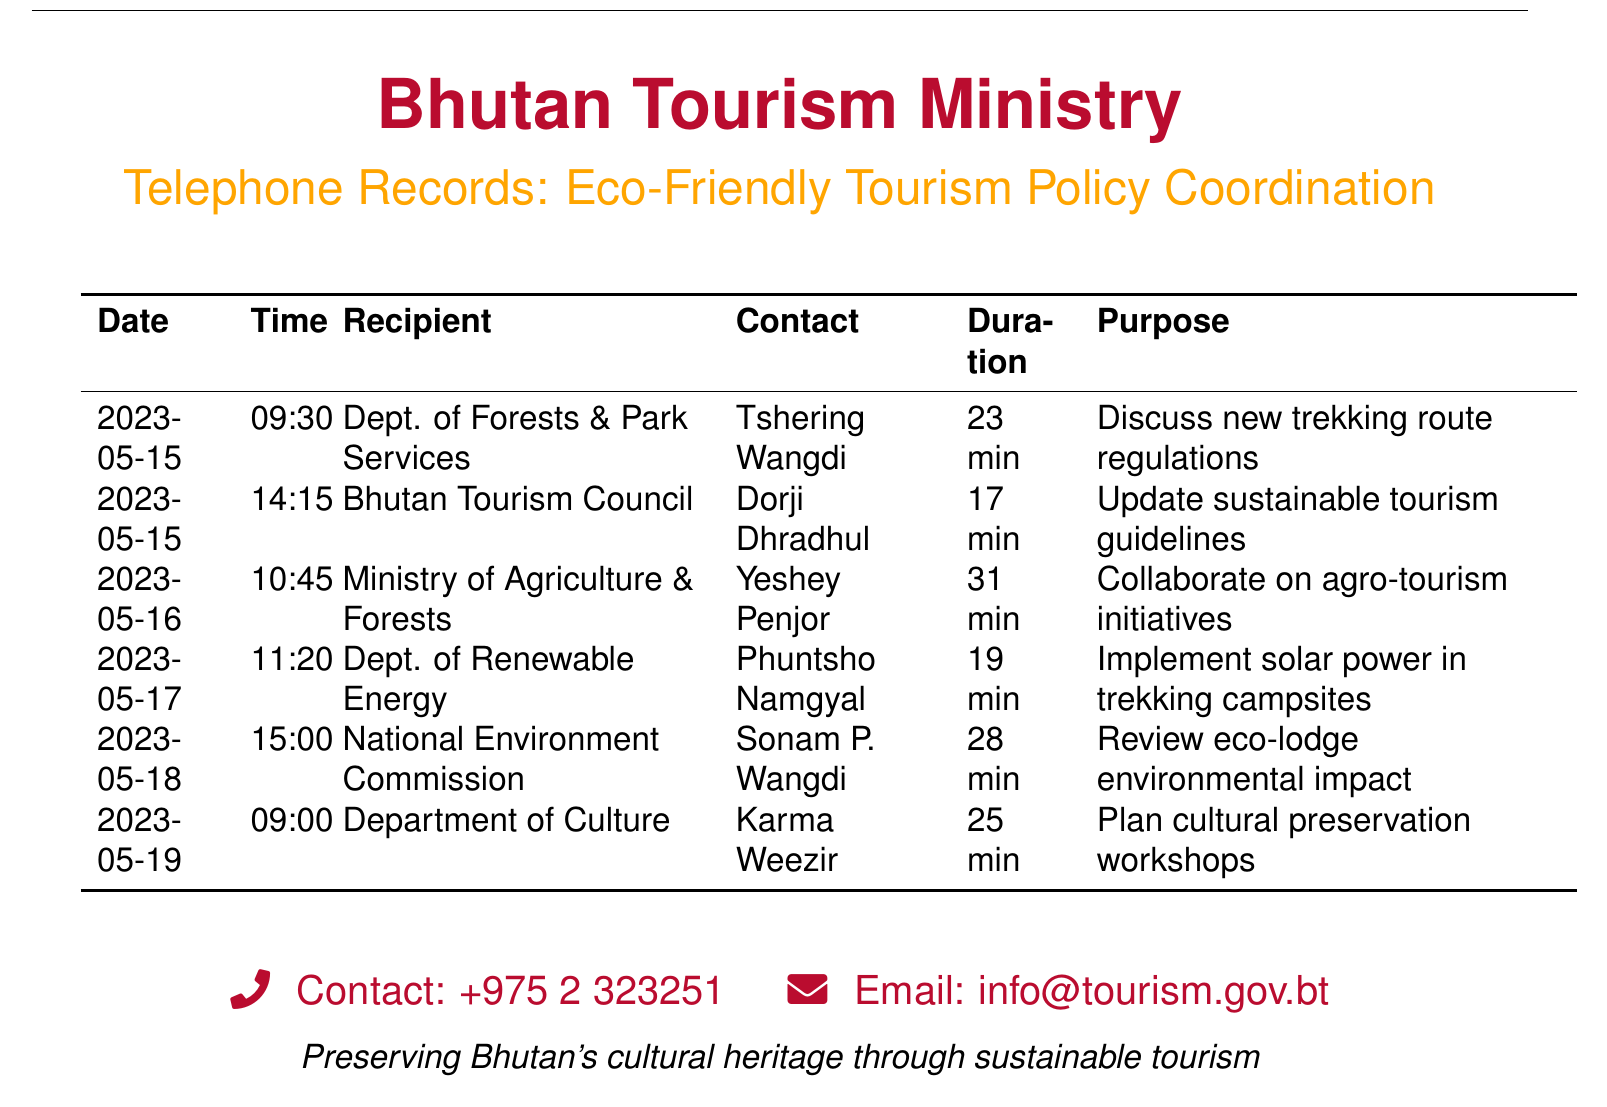what is the date of the call to the Dept. of Forests & Park Services? The date of the call is mentioned in the document under the Date column for the specified department.
Answer: 2023-05-15 who was called at the Bhutan Tourism Council? The name of the person called at the Bhutan Tourism Council is listed in the document under the Recipient and Contact columns.
Answer: Dorji Dhradhul how long was the conversation with the Ministry of Agriculture & Forests? The duration of the conversation is provided in the Duration column in the document for this specific call.
Answer: 31 min what was the purpose of the call to the Department of Culture? The purpose of the call is specified in the Purpose column for the Department of Culture.
Answer: Plan cultural preservation workshops which department discussed implementing solar power? The department that discussed solar power is in the document under the Recipient column for the specific call logged.
Answer: Dept. of Renewable Energy how many minutes did the call to the National Environment Commission last? The duration of the call is noted in the Duration column specifically for National Environment Commission.
Answer: 28 min which person is associated with the call about new trekking route regulations? The person associated with this call is provided in the Contact column for the specified date and department.
Answer: Tshering Wangdi what is the purpose of the call with Bhutan Tourism Council? The purpose of the call is given in the Purpose column under Bhutan Tourism Council in the document.
Answer: Update sustainable tourism guidelines 